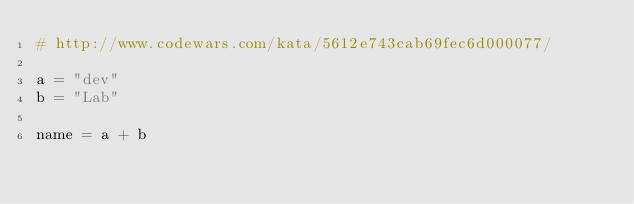<code> <loc_0><loc_0><loc_500><loc_500><_Python_># http://www.codewars.com/kata/5612e743cab69fec6d000077/

a = "dev"
b = "Lab"

name = a + b
</code> 